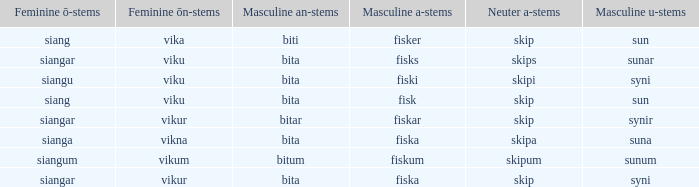What is the an-stem for the word which has an ö-stems of siangar and an u-stem ending of syni? Bita. 